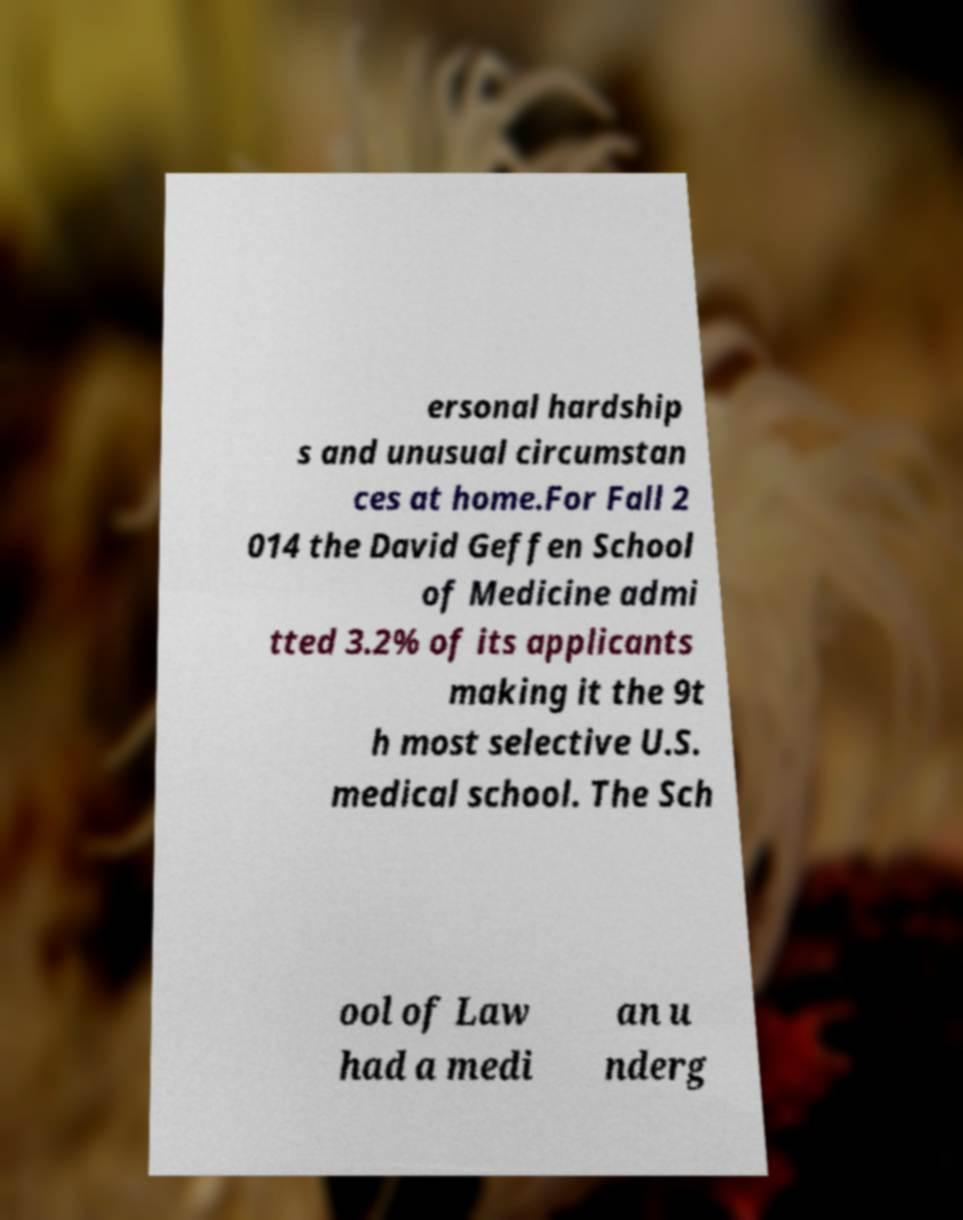Can you read and provide the text displayed in the image?This photo seems to have some interesting text. Can you extract and type it out for me? ersonal hardship s and unusual circumstan ces at home.For Fall 2 014 the David Geffen School of Medicine admi tted 3.2% of its applicants making it the 9t h most selective U.S. medical school. The Sch ool of Law had a medi an u nderg 